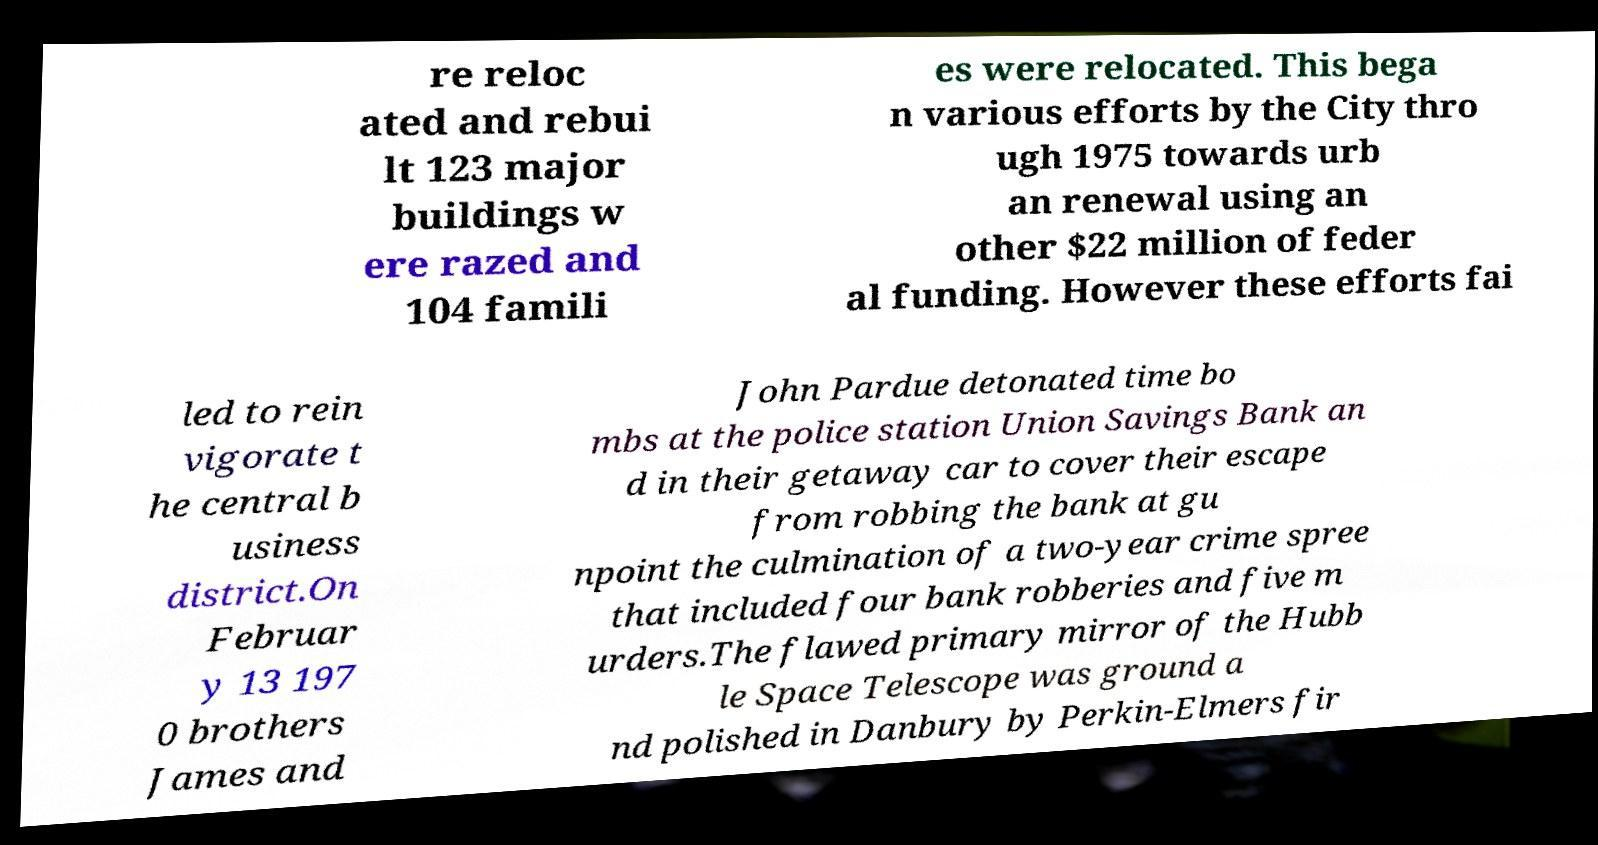Can you accurately transcribe the text from the provided image for me? re reloc ated and rebui lt 123 major buildings w ere razed and 104 famili es were relocated. This bega n various efforts by the City thro ugh 1975 towards urb an renewal using an other $22 million of feder al funding. However these efforts fai led to rein vigorate t he central b usiness district.On Februar y 13 197 0 brothers James and John Pardue detonated time bo mbs at the police station Union Savings Bank an d in their getaway car to cover their escape from robbing the bank at gu npoint the culmination of a two-year crime spree that included four bank robberies and five m urders.The flawed primary mirror of the Hubb le Space Telescope was ground a nd polished in Danbury by Perkin-Elmers fir 